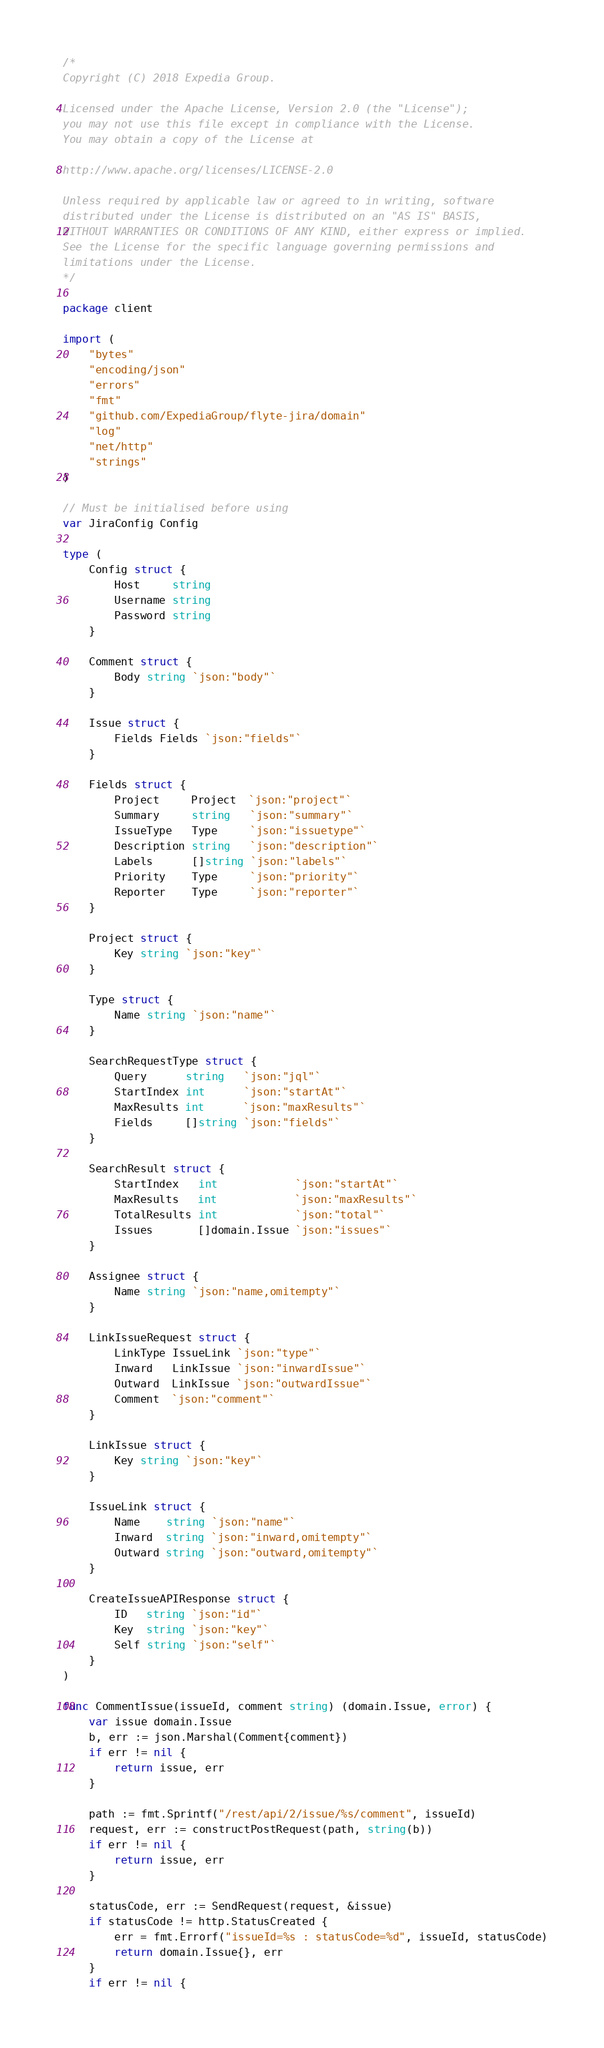Convert code to text. <code><loc_0><loc_0><loc_500><loc_500><_Go_>/*
Copyright (C) 2018 Expedia Group.

Licensed under the Apache License, Version 2.0 (the "License");
you may not use this file except in compliance with the License.
You may obtain a copy of the License at

http://www.apache.org/licenses/LICENSE-2.0

Unless required by applicable law or agreed to in writing, software
distributed under the License is distributed on an "AS IS" BASIS,
WITHOUT WARRANTIES OR CONDITIONS OF ANY KIND, either express or implied.
See the License for the specific language governing permissions and
limitations under the License.
*/

package client

import (
	"bytes"
	"encoding/json"
	"errors"
	"fmt"
	"github.com/ExpediaGroup/flyte-jira/domain"
	"log"
	"net/http"
	"strings"
)

// Must be initialised before using
var JiraConfig Config

type (
	Config struct {
		Host     string
		Username string
		Password string
	}

	Comment struct {
		Body string `json:"body"`
	}

	Issue struct {
		Fields Fields `json:"fields"`
	}

	Fields struct {
		Project     Project  `json:"project"`
		Summary     string   `json:"summary"`
		IssueType   Type     `json:"issuetype"`
		Description string   `json:"description"`
		Labels      []string `json:"labels"`
		Priority    Type     `json:"priority"`
		Reporter    Type     `json:"reporter"`
	}

	Project struct {
		Key string `json:"key"`
	}

	Type struct {
		Name string `json:"name"`
	}

	SearchRequestType struct {
		Query      string   `json:"jql"`
		StartIndex int      `json:"startAt"`
		MaxResults int      `json:"maxResults"`
		Fields     []string `json:"fields"`
	}

	SearchResult struct {
		StartIndex   int            `json:"startAt"`
		MaxResults   int            `json:"maxResults"`
		TotalResults int            `json:"total"`
		Issues       []domain.Issue `json:"issues"`
	}

	Assignee struct {
		Name string `json:"name,omitempty"`
	}

	LinkIssueRequest struct {
		LinkType IssueLink `json:"type"`
		Inward   LinkIssue `json:"inwardIssue"`
		Outward  LinkIssue `json:"outwardIssue"`
		Comment  `json:"comment"`
	}

	LinkIssue struct {
		Key string `json:"key"`
	}

	IssueLink struct {
		Name    string `json:"name"`
		Inward  string `json:"inward,omitempty"`
		Outward string `json:"outward,omitempty"`
	}

	CreateIssueAPIResponse struct {
		ID   string `json:"id"`
		Key  string `json:"key"`
		Self string `json:"self"`
	}
)

func CommentIssue(issueId, comment string) (domain.Issue, error) {
	var issue domain.Issue
	b, err := json.Marshal(Comment{comment})
	if err != nil {
		return issue, err
	}

	path := fmt.Sprintf("/rest/api/2/issue/%s/comment", issueId)
	request, err := constructPostRequest(path, string(b))
	if err != nil {
		return issue, err
	}

	statusCode, err := SendRequest(request, &issue)
	if statusCode != http.StatusCreated {
		err = fmt.Errorf("issueId=%s : statusCode=%d", issueId, statusCode)
		return domain.Issue{}, err
	}
	if err != nil {</code> 